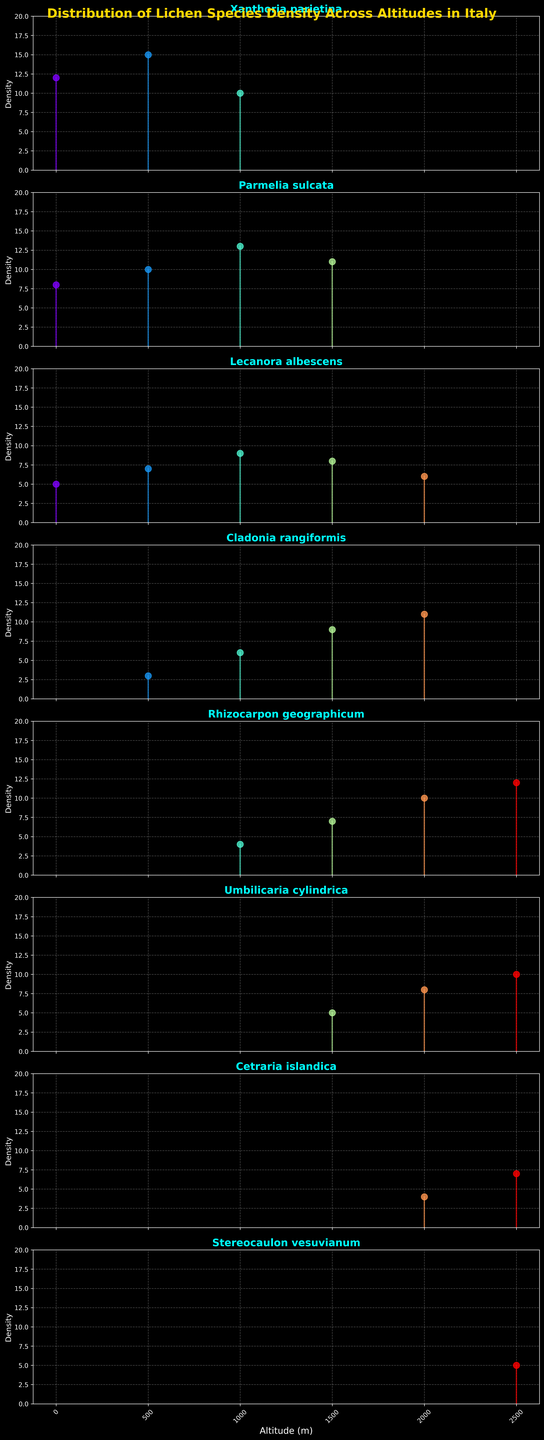What is the title of the figure? The title of the figure is usually displayed at the top, often in larger and bold font. Looking at the plot, you can read the title directly.
Answer: Distribution of Lichen Species Density Across Altitudes in Italy What is the highest density recorded for 'Cladonia rangiformis'? For 'Cladonia rangiformis', track the lines and points overlay corresponding to altitudes. The highest point on the plot represents the peak density.
Answer: 11 Which species are represented in the subplot for the density plots? Each subplot line corresponds to one species. By reading the titles of each subplot, we identify the species.
Answer: Xanthoria parietina, Parmelia sulcata, Lecanora albescens, Cladonia rangiformis, Rhizocarpon geographicum, Umbilicaria cylindrica, Cetraria islandica, Stereocaulon vesuvianum At which altitude does 'Parmelia sulcata' have the highest density? Look at the subplot for 'Parmelia sulcata'. Compare the density lines at various altitudes to find the highest one.
Answer: 1000m Which species has the lowest density recorded at 0m altitude? For altitude 0m, examine the density points for each species at that altitude, and the lowest point indicates the species with the lowest density.
Answer: Lecanora albescens Between which altitudes does 'Rhizocarpon geographicum' show a continual increase in density? Observe the trend in the 'Rhizocarpon geographicum' subplot from left to right and note where the continuous upward slope occurs.
Answer: 1000m to 2500m How many species have their density peaking at 1500m altitude? Review each subplot to find the species having the highest density point at 1500m. Count these species.
Answer: 1 Which species show a decrease in density from 2000m to 2500m? Look at the trend in the density lines or points from 2000m to 2500m for each species and identify those with a downward slope.
Answer: Umbilicaria cylindrica Which species have data points plotted at 2500m altitude? Identify the species that have a visible density point plotted on the 2500m altitude line in each subplot.
Answer: Rhizocarpon geographicum, Umbilicaria cylindrica, Cetraria islandica, Stereocaulon vesuvianum 